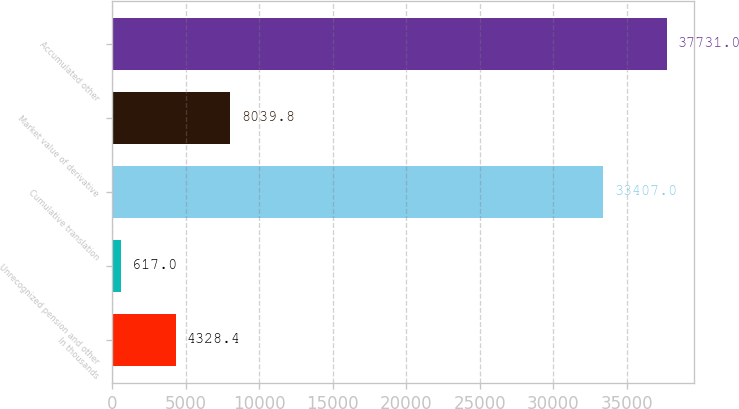Convert chart to OTSL. <chart><loc_0><loc_0><loc_500><loc_500><bar_chart><fcel>In thousands<fcel>Unrecognized pension and other<fcel>Cumulative translation<fcel>Market value of derivative<fcel>Accumulated other<nl><fcel>4328.4<fcel>617<fcel>33407<fcel>8039.8<fcel>37731<nl></chart> 